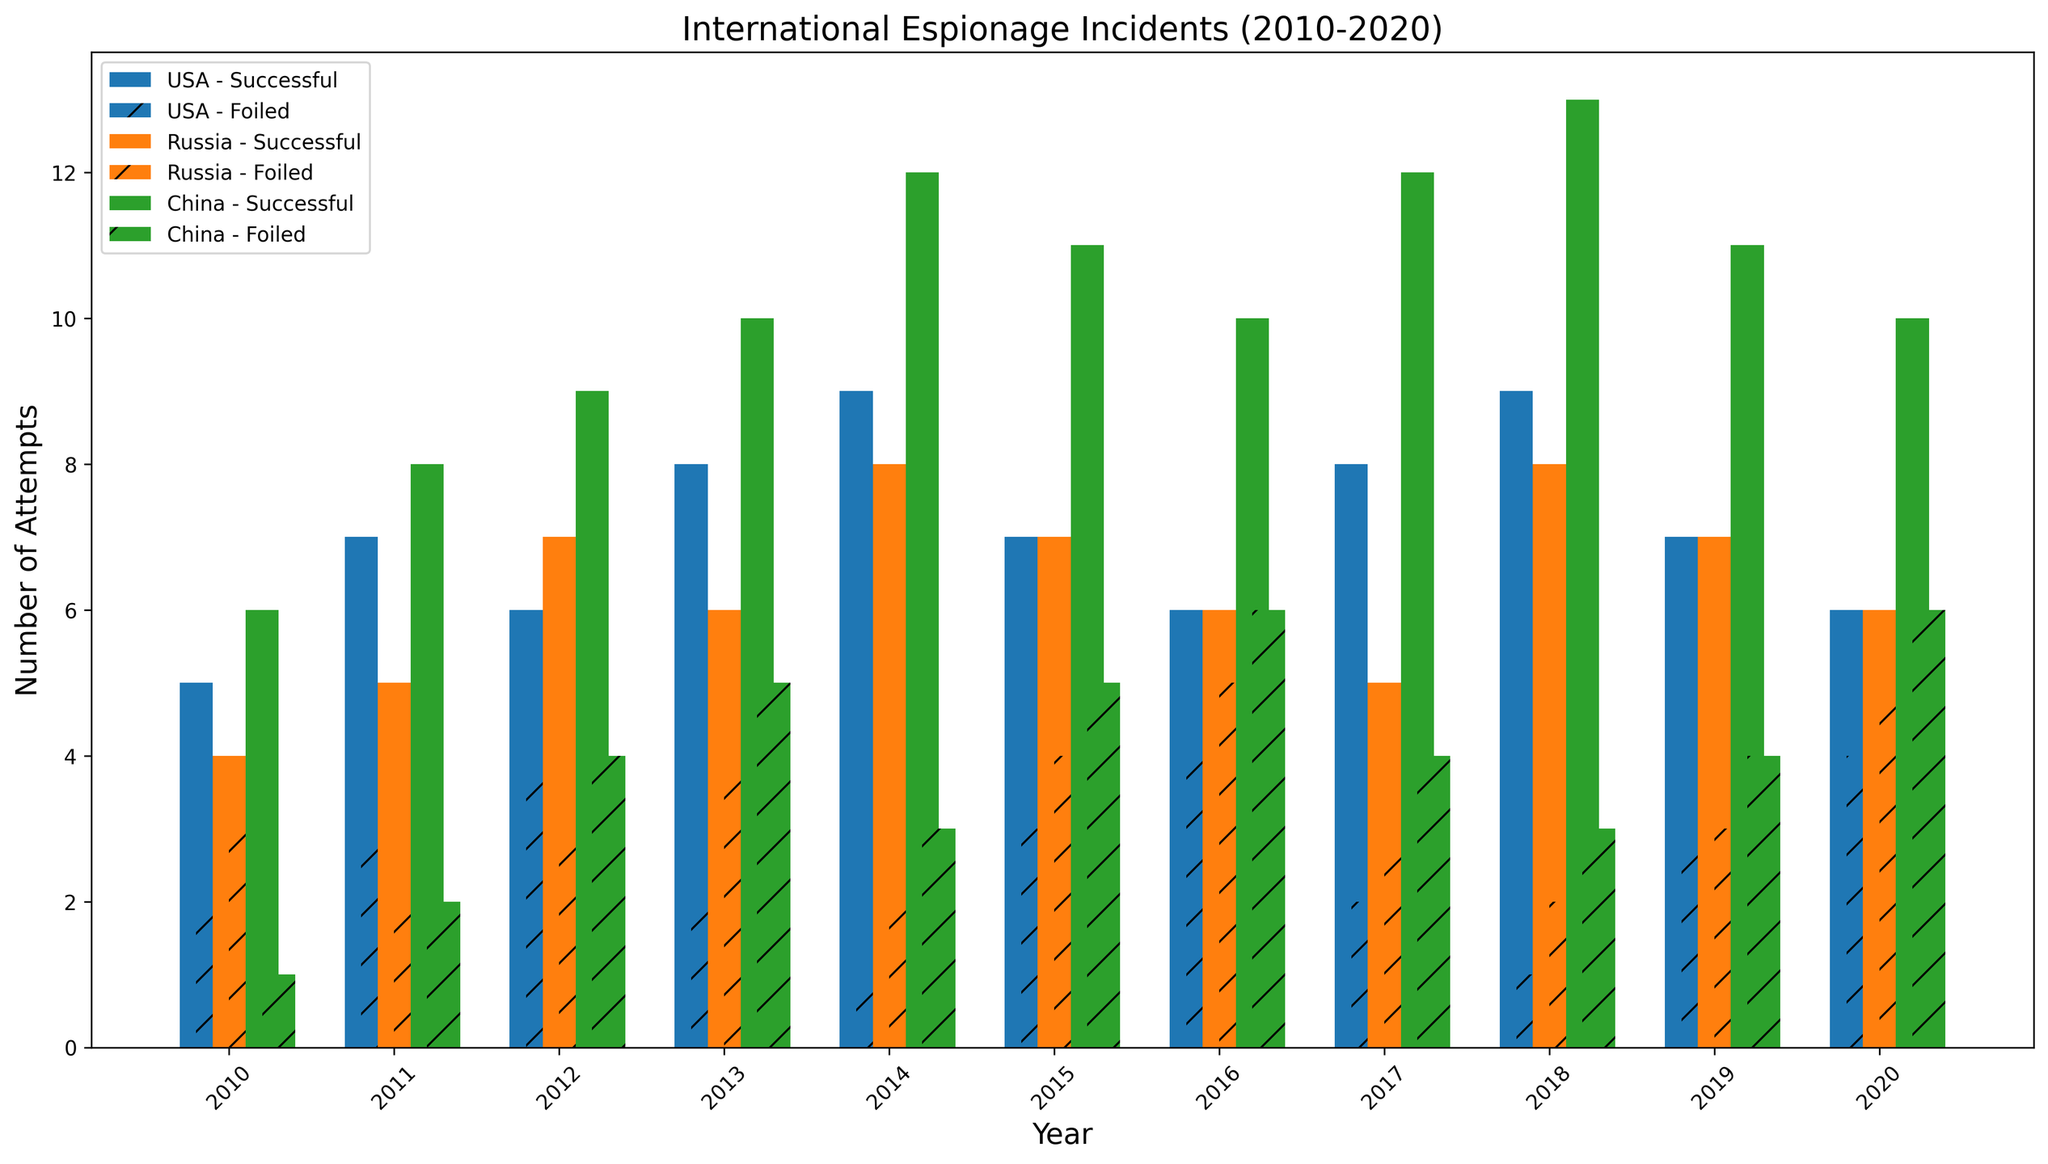Which country had the most successful espionage attempts in 2013? To answer this question, identify the bars corresponding to successful attempts for each country in 2013. The tallest bar represents the country with the most successful attempts. In 2013, the highest bar for successful attempts is for China.
Answer: China In which year did the USA have an equal number of successful and foiled attempts? Find the USA's bars for each year and look for a year where the heights of the bars for successful and foiled attempts are the same. In 2012, both bars are equal for the USA.
Answer: 2012 What is the total number of espionage attempts (successful + foiled) for Russia in 2014? Add the heights of the bars for successful and foiled attempts for Russia in 2014. The bar for successful attempts is 8 and for foiled attempts is 2. Therefore, 8 + 2 = 10.
Answer: 10 Which country has more successful espionage attempts: China in 2018 or the USA in 2014? Compare the heights of the successful attempts bar for China in 2018 and the USA in 2014. China's bar is taller with 13 successful attempts compared to the USA's 9 successful attempts.
Answer: China Based on visual inspection, which country consistently has the highest number of successful attempts from 2010 to 2020? Observe the successful attempts bars' height for each country across all years. China's bars appear to be consistently taller than those of the USA and Russia.
Answer: China In 2017, which country had more foiled espionage attempts: USA or Russia? Compare the heights of the foiled attempts bars for the USA and Russia in 2017. Russia's bar is taller with 3 foiled attempts compared to the USA's 2 foiled attempts.
Answer: Russia Did China’s foiled attempts increase or decrease from 2016 to 2017? Compare the height of China's foiled attempts bar in 2016 with that in 2017. The bar decreases from 6 foiled attempts in 2016 to 4 in 2017.
Answer: Decrease What is the difference in successful espionage attempts between the USA and Russia in 2019? Subtract the height of Russia's successful attempts bar from the USA’s in 2019. The USA has 7 successful attempts, and Russia has 7, so 7 - 7 = 0.
Answer: 0 Which year did the USA have the highest number of successful espionage attempts? Find the tallest bar for the USA’s successful attempts across all years. The tallest bar for the USA is in 2018 with 9 successful attempts.
Answer: 2018 